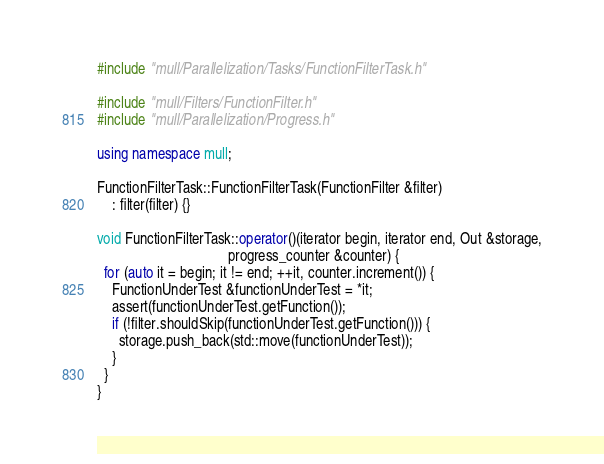Convert code to text. <code><loc_0><loc_0><loc_500><loc_500><_C++_>#include "mull/Parallelization/Tasks/FunctionFilterTask.h"

#include "mull/Filters/FunctionFilter.h"
#include "mull/Parallelization/Progress.h"

using namespace mull;

FunctionFilterTask::FunctionFilterTask(FunctionFilter &filter)
    : filter(filter) {}

void FunctionFilterTask::operator()(iterator begin, iterator end, Out &storage,
                                    progress_counter &counter) {
  for (auto it = begin; it != end; ++it, counter.increment()) {
    FunctionUnderTest &functionUnderTest = *it;
    assert(functionUnderTest.getFunction());
    if (!filter.shouldSkip(functionUnderTest.getFunction())) {
      storage.push_back(std::move(functionUnderTest));
    }
  }
}
</code> 